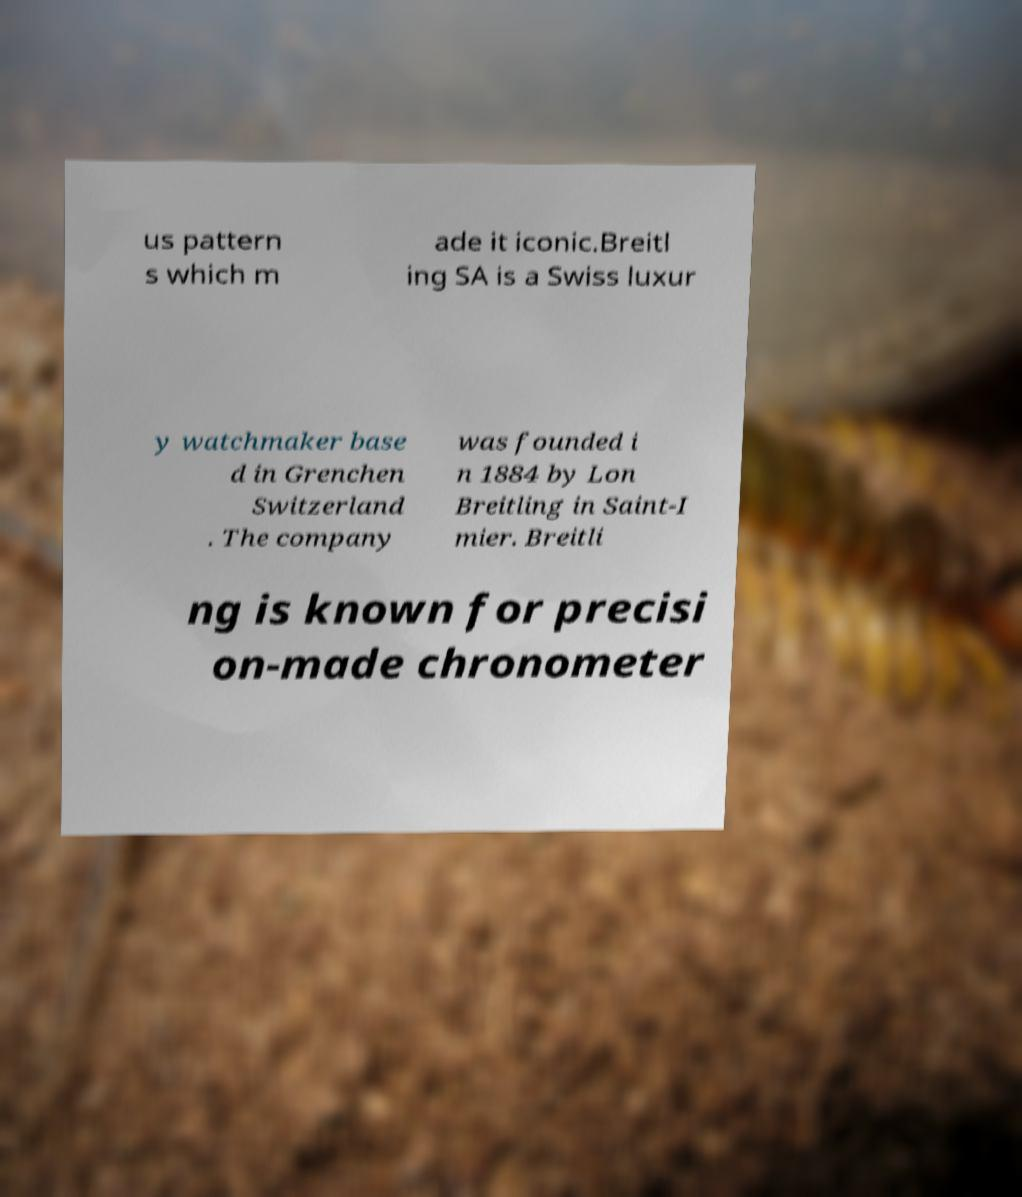I need the written content from this picture converted into text. Can you do that? us pattern s which m ade it iconic.Breitl ing SA is a Swiss luxur y watchmaker base d in Grenchen Switzerland . The company was founded i n 1884 by Lon Breitling in Saint-I mier. Breitli ng is known for precisi on-made chronometer 